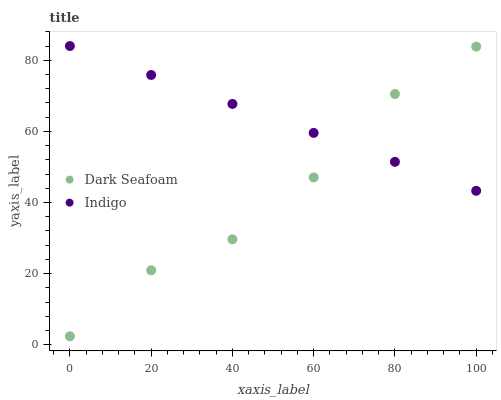Does Dark Seafoam have the minimum area under the curve?
Answer yes or no. Yes. Does Indigo have the maximum area under the curve?
Answer yes or no. Yes. Does Indigo have the minimum area under the curve?
Answer yes or no. No. Is Indigo the smoothest?
Answer yes or no. Yes. Is Dark Seafoam the roughest?
Answer yes or no. Yes. Is Indigo the roughest?
Answer yes or no. No. Does Dark Seafoam have the lowest value?
Answer yes or no. Yes. Does Indigo have the lowest value?
Answer yes or no. No. Does Indigo have the highest value?
Answer yes or no. Yes. Does Dark Seafoam intersect Indigo?
Answer yes or no. Yes. Is Dark Seafoam less than Indigo?
Answer yes or no. No. Is Dark Seafoam greater than Indigo?
Answer yes or no. No. 